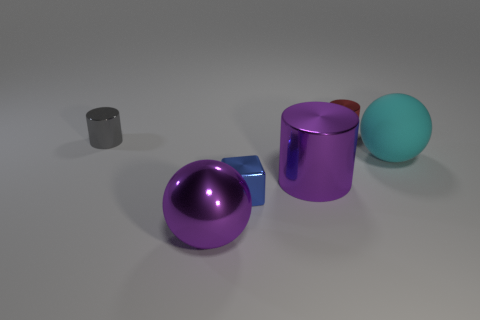Is there anything else that is made of the same material as the big cyan thing?
Provide a short and direct response. No. Is the red shiny object the same shape as the tiny gray shiny thing?
Offer a very short reply. Yes. There is a object that is the same color as the shiny ball; what shape is it?
Your response must be concise. Cylinder. What shape is the shiny thing that is the same size as the purple cylinder?
Give a very brief answer. Sphere. Is the number of big matte balls in front of the small gray metal object greater than the number of small cylinders in front of the large cyan matte thing?
Keep it short and to the point. Yes. Do the cylinder that is left of the metallic block and the big thing to the left of the large shiny cylinder have the same material?
Ensure brevity in your answer.  Yes. Are there any rubber spheres left of the cyan ball?
Give a very brief answer. No. How many red objects are either tiny shiny cubes or shiny objects?
Your response must be concise. 1. Do the tiny red cylinder and the thing that is in front of the metal block have the same material?
Ensure brevity in your answer.  Yes. What is the size of the purple thing that is the same shape as the gray shiny object?
Your response must be concise. Large. 